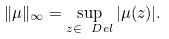<formula> <loc_0><loc_0><loc_500><loc_500>\| \mu \| _ { \infty } = \sup _ { z \in \ D e l } | \mu ( z ) | .</formula> 